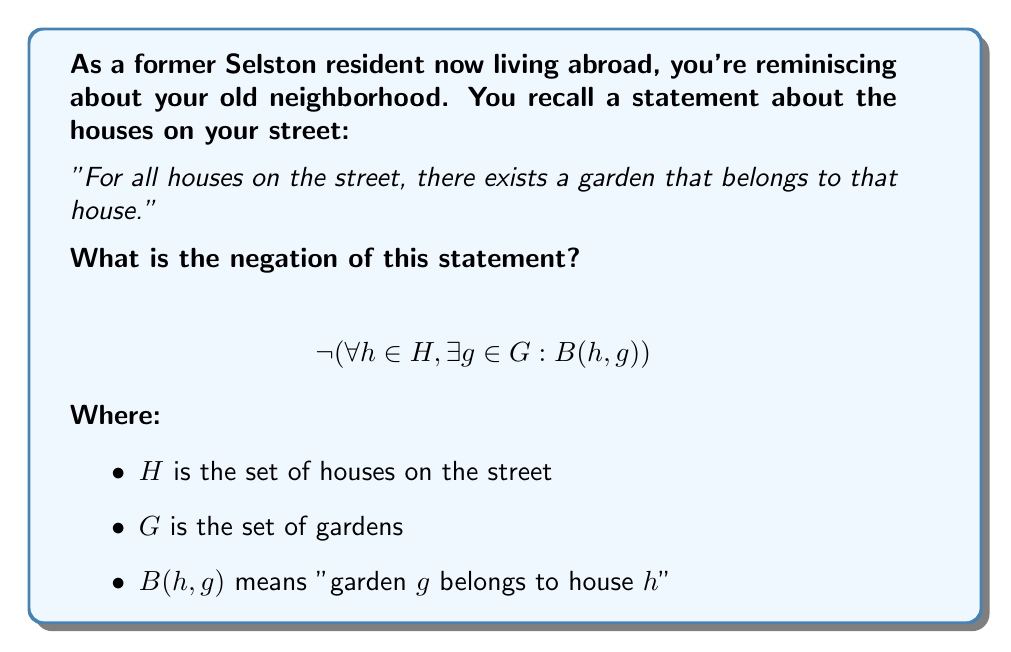Can you answer this question? To negate a quantified statement, we follow these steps:

1. Change the order of quantifiers:
   - $\forall$ (for all) becomes $\exists$ (there exists)
   - $\exists$ (there exists) becomes $\forall$ (for all)

2. Negate the inner statement

Starting with:
$$\forall h \in H, \exists g \in G : B(h,g)$$

Step 1: Change the order of quantifiers
$$\exists h \in H, \forall g \in G : \neg B(h,g)$$

Step 2: Negate the inner statement
The negation of $B(h,g)$ is simply $\neg B(h,g)$

Therefore, the complete negation is:
$$\exists h \in H, \forall g \in G : \neg B(h,g)$$

In natural language, this translates to:
"There exists a house on the street for which all gardens do not belong to that house."

Or more simply:
"There is at least one house on the street that doesn't have any garden belonging to it."
Answer: $$\exists h \in H, \forall g \in G : \neg B(h,g)$$ 